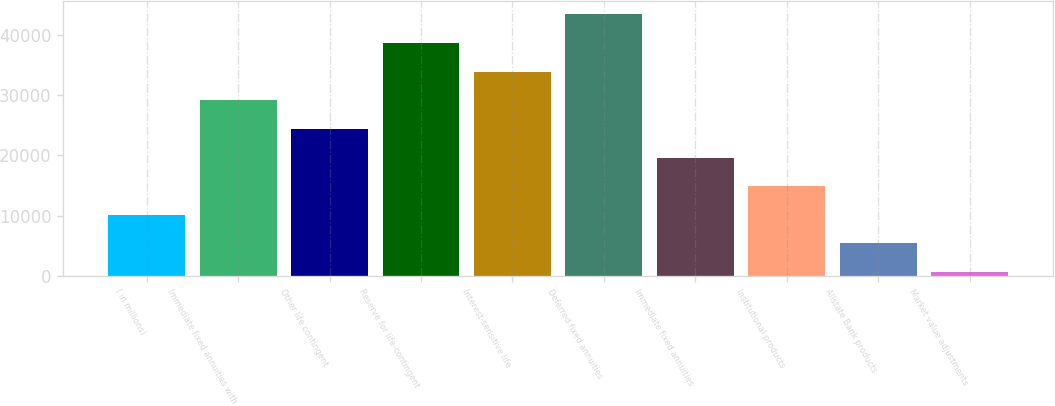Convert chart to OTSL. <chart><loc_0><loc_0><loc_500><loc_500><bar_chart><fcel>( in millions)<fcel>Immediate fixed annuities with<fcel>Other life contingent<fcel>Reserve for life-contingent<fcel>Interest-sensitive life<fcel>Deferred fixed annuities<fcel>Immediate fixed annuities<fcel>Institutional products<fcel>Allstate Bank products<fcel>Market value adjustments<nl><fcel>10129.4<fcel>29162.2<fcel>24404<fcel>38678.6<fcel>33920.4<fcel>43436.8<fcel>19645.8<fcel>14887.6<fcel>5371.2<fcel>613<nl></chart> 